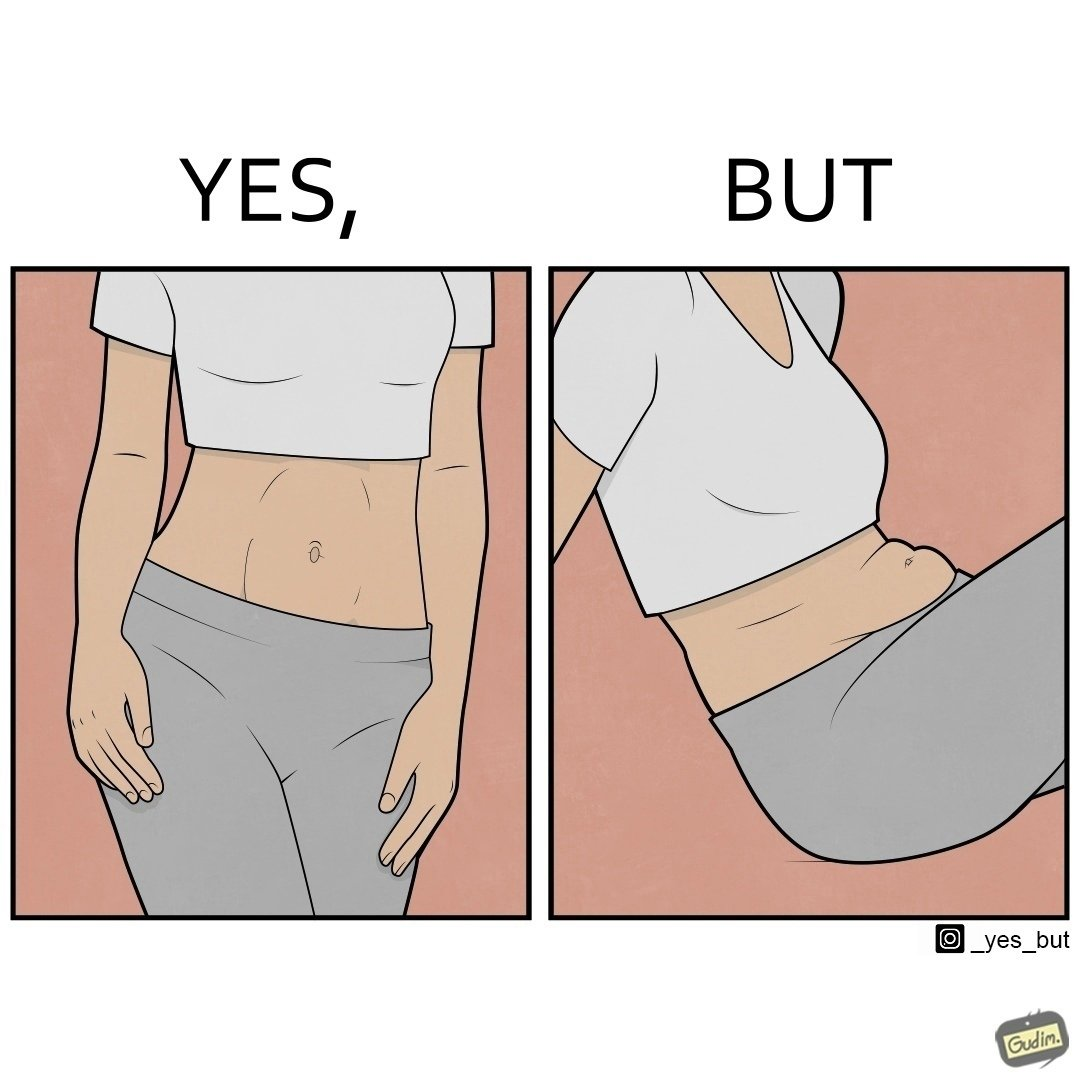What does this image depict? the image is funny, as from the front, the woman is apparently slim, but she looks chubby from the side. 